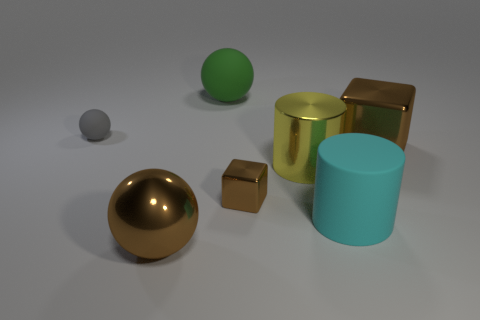There is a big block that is the same color as the small metal object; what is its material? metal 